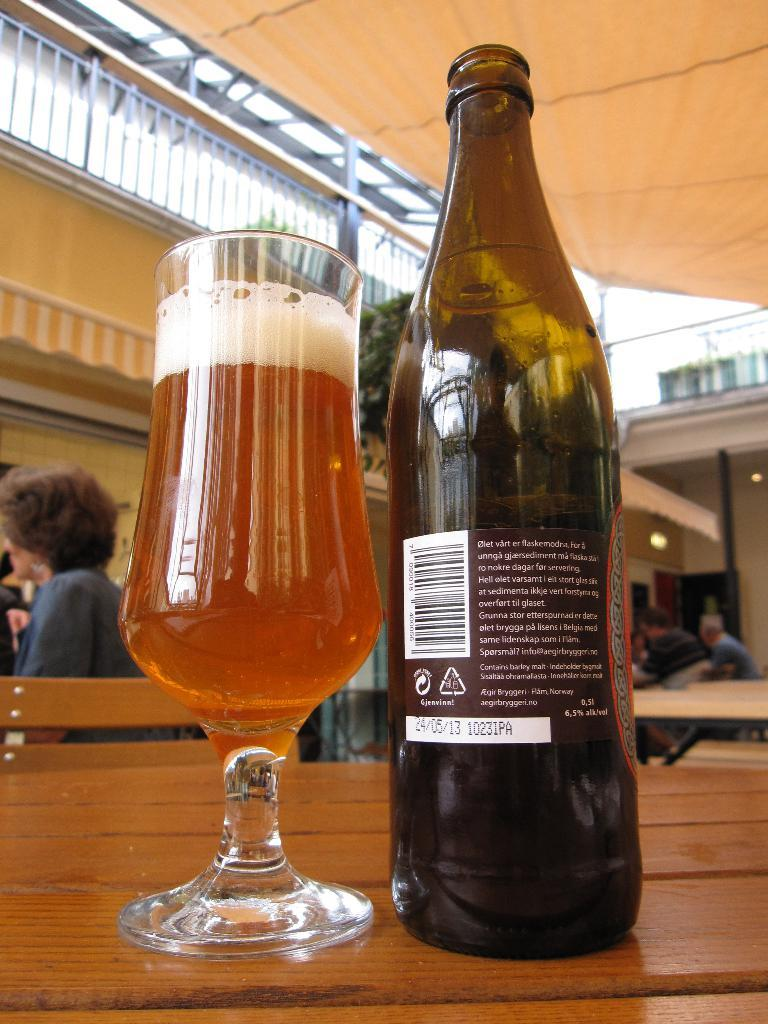What type of drink is in the glass that is visible in the image? There is a glass of wine in the image. What other item related to wine can be seen in the image? There is a wine bottle in the image. Where are the glass and bottle located in the image? Both the glass and bottle are on a table. What can be seen in the background of the image? There are people sitting, a tent, a building, lights, and a pole visible in the background. Can you see a snake slithering across the table in the image? No, there is no snake present in the image. What type of work are the people in the background doing? The image does not provide any information about the people's activities or work. 